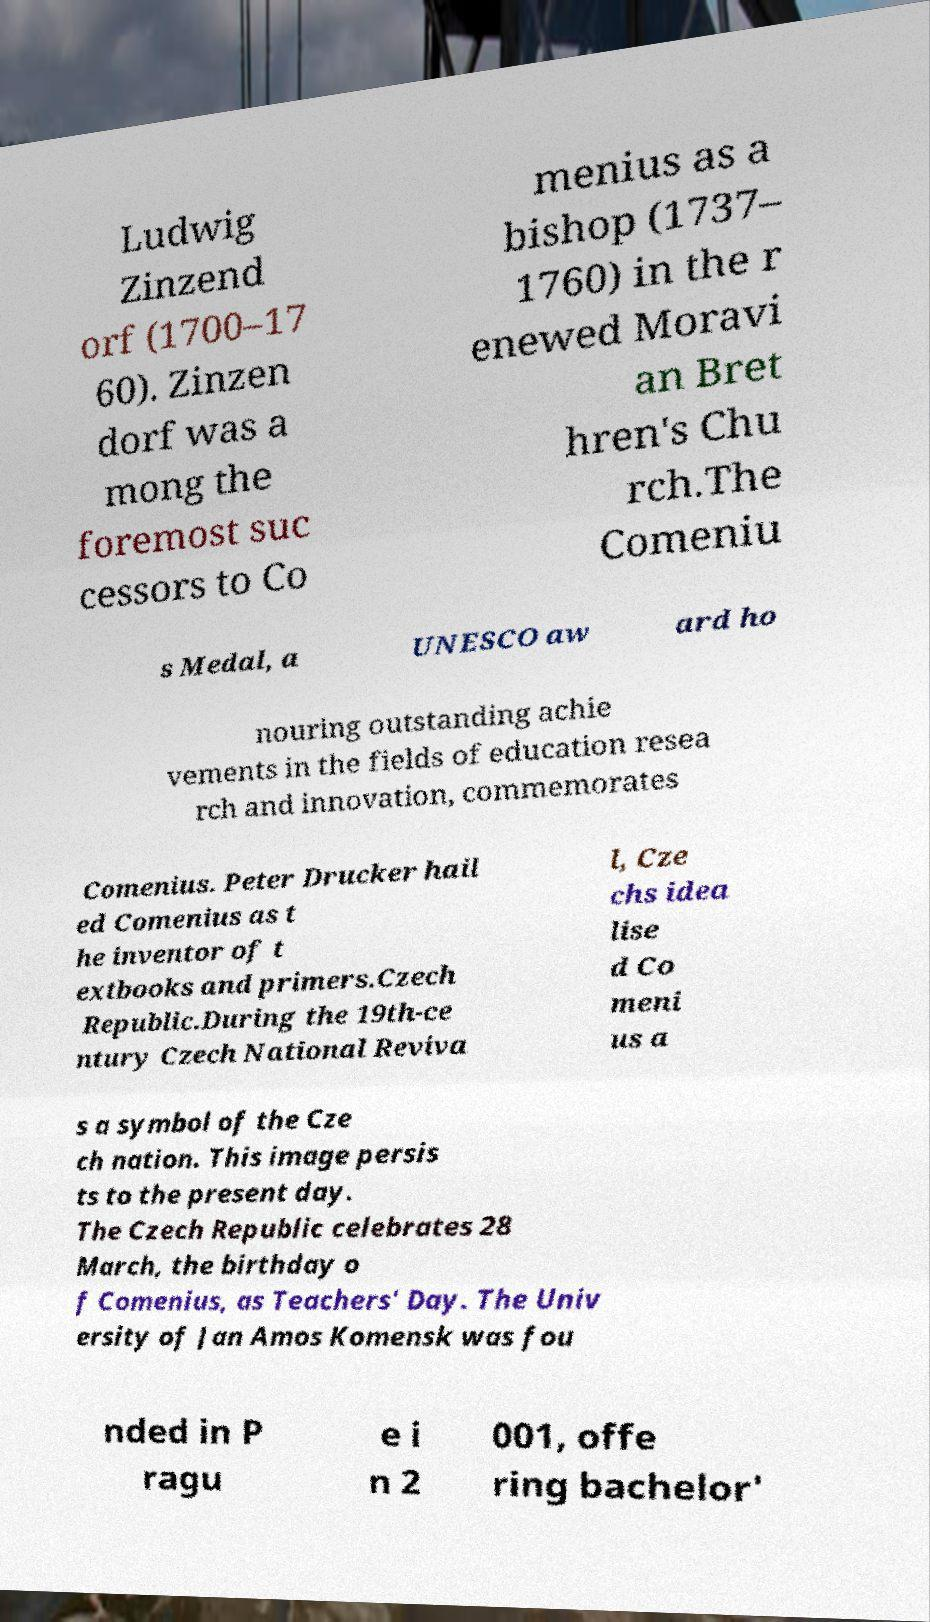Please identify and transcribe the text found in this image. Ludwig Zinzend orf (1700–17 60). Zinzen dorf was a mong the foremost suc cessors to Co menius as a bishop (1737– 1760) in the r enewed Moravi an Bret hren's Chu rch.The Comeniu s Medal, a UNESCO aw ard ho nouring outstanding achie vements in the fields of education resea rch and innovation, commemorates Comenius. Peter Drucker hail ed Comenius as t he inventor of t extbooks and primers.Czech Republic.During the 19th-ce ntury Czech National Reviva l, Cze chs idea lise d Co meni us a s a symbol of the Cze ch nation. This image persis ts to the present day. The Czech Republic celebrates 28 March, the birthday o f Comenius, as Teachers' Day. The Univ ersity of Jan Amos Komensk was fou nded in P ragu e i n 2 001, offe ring bachelor' 